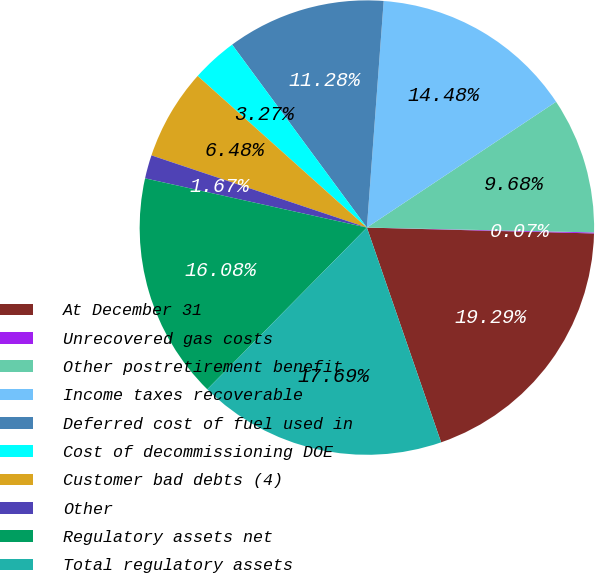<chart> <loc_0><loc_0><loc_500><loc_500><pie_chart><fcel>At December 31<fcel>Unrecovered gas costs<fcel>Other postretirement benefit<fcel>Income taxes recoverable<fcel>Deferred cost of fuel used in<fcel>Cost of decommissioning DOE<fcel>Customer bad debts (4)<fcel>Other<fcel>Regulatory assets net<fcel>Total regulatory assets<nl><fcel>19.29%<fcel>0.07%<fcel>9.68%<fcel>14.48%<fcel>11.28%<fcel>3.27%<fcel>6.48%<fcel>1.67%<fcel>16.08%<fcel>17.69%<nl></chart> 